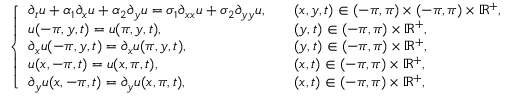<formula> <loc_0><loc_0><loc_500><loc_500>\left \{ \begin{array} { l l } { \partial _ { t } u + \alpha _ { 1 } \partial _ { x } u + \alpha _ { 2 } \partial _ { y } u = \sigma _ { 1 } \partial _ { x x } u + \sigma _ { 2 } \partial _ { y y } u , \quad } & { ( x , y , t ) \in ( - \pi , \pi ) \times ( - \pi , \pi ) \times \mathbb { R } ^ { + } , } \\ { u ( - \pi , y , t ) = u ( \pi , y , t ) , } & { ( y , t ) \in ( - \pi , \pi ) \times \mathbb { R } ^ { + } , } \\ { \partial _ { x } u ( - \pi , y , t ) = \partial _ { x } u ( \pi , y , t ) , } & { ( y , t ) \in ( - \pi , \pi ) \times \mathbb { R } ^ { + } , } \\ { u ( x , - \pi , t ) = u ( x , \pi , t ) , } & { ( x , t ) \in ( - \pi , \pi ) \times \mathbb { R } ^ { + } , } \\ { \partial _ { y } u ( x , - \pi , t ) = \partial _ { y } u ( x , \pi , t ) , } & { ( x , t ) \in ( - \pi , \pi ) \times \mathbb { R } ^ { + } , } \end{array}</formula> 